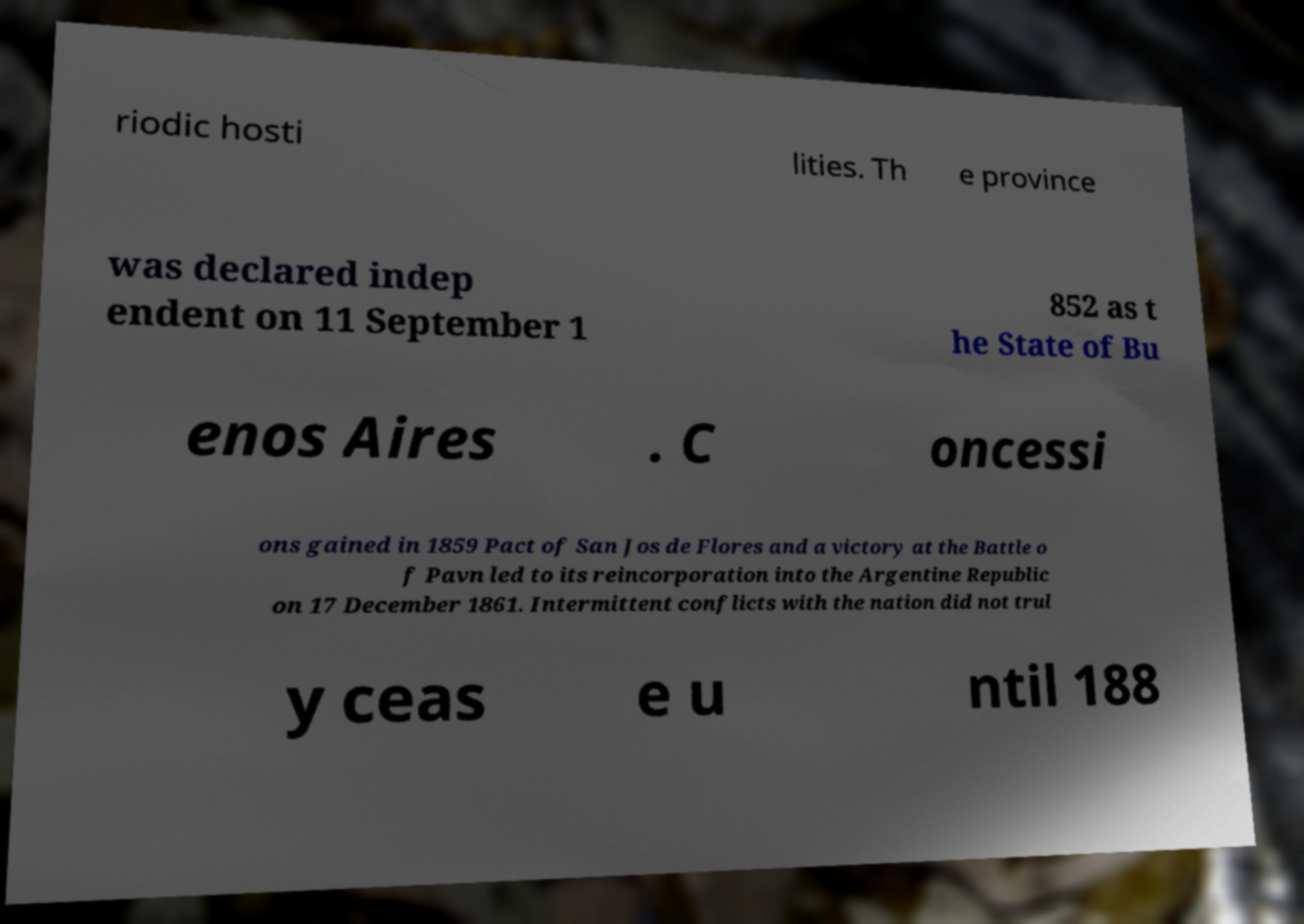For documentation purposes, I need the text within this image transcribed. Could you provide that? riodic hosti lities. Th e province was declared indep endent on 11 September 1 852 as t he State of Bu enos Aires . C oncessi ons gained in 1859 Pact of San Jos de Flores and a victory at the Battle o f Pavn led to its reincorporation into the Argentine Republic on 17 December 1861. Intermittent conflicts with the nation did not trul y ceas e u ntil 188 